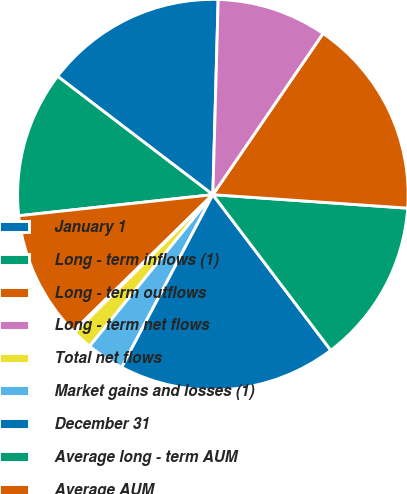<chart> <loc_0><loc_0><loc_500><loc_500><pie_chart><fcel>January 1<fcel>Long - term inflows (1)<fcel>Long - term outflows<fcel>Long - term net flows<fcel>Total net flows<fcel>Market gains and losses (1)<fcel>December 31<fcel>Average long - term AUM<fcel>Average AUM<fcel>Gross revenue yield on AUM (2)<nl><fcel>15.07%<fcel>12.09%<fcel>10.6%<fcel>0.16%<fcel>1.65%<fcel>3.14%<fcel>18.05%<fcel>13.58%<fcel>16.56%<fcel>9.11%<nl></chart> 